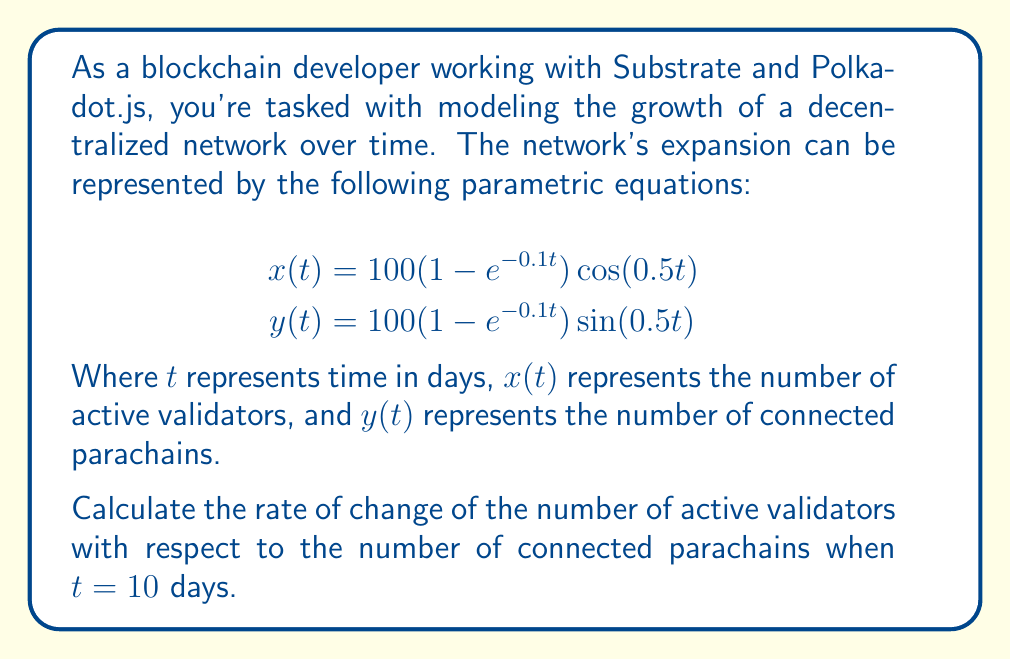Give your solution to this math problem. To solve this problem, we need to find $\frac{dx}{dy}$ when $t = 10$. We can do this using the following steps:

1. Calculate $\frac{dx}{dt}$ and $\frac{dy}{dt}$:

$$\begin{align}
\frac{dx}{dt} &= 10e^{-0.1t}\cos(0.5t) - 50(1-e^{-0.1t})\sin(0.5t) \\
\frac{dy}{dt} &= 10e^{-0.1t}\sin(0.5t) + 50(1-e^{-0.1t})\cos(0.5t)
\end{align}$$

2. Use the chain rule to find $\frac{dx}{dy}$:

$$\frac{dx}{dy} = \frac{dx/dt}{dy/dt}$$

3. Substitute $t = 10$ into the equations for $\frac{dx}{dt}$ and $\frac{dy}{dt}$:

$$\begin{align}
\frac{dx}{dt}|_{t=10} &= 10e^{-1}\cos(5) - 50(1-e^{-1})\sin(5) \\
\frac{dy}{dt}|_{t=10} &= 10e^{-1}\sin(5) + 50(1-e^{-1})\cos(5)
\end{align}$$

4. Calculate the numerical values:

$$\begin{align}
\frac{dx}{dt}|_{t=10} &\approx 3.6788 \cdot 0.2837 - 31.6212 \cdot (-0.9589) \approx 31.3741 \\
\frac{dy}{dt}|_{t=10} &\approx 3.6788 \cdot (-0.9589) + 31.6212 \cdot 0.2837 \approx 5.4287
\end{align}$$

5. Calculate $\frac{dx}{dy}$ at $t = 10$:

$$\frac{dx}{dy}|_{t=10} = \frac{31.3741}{5.4287} \approx 5.7793$$
Answer: The rate of change of the number of active validators with respect to the number of connected parachains when $t = 10$ days is approximately $5.7793$. 